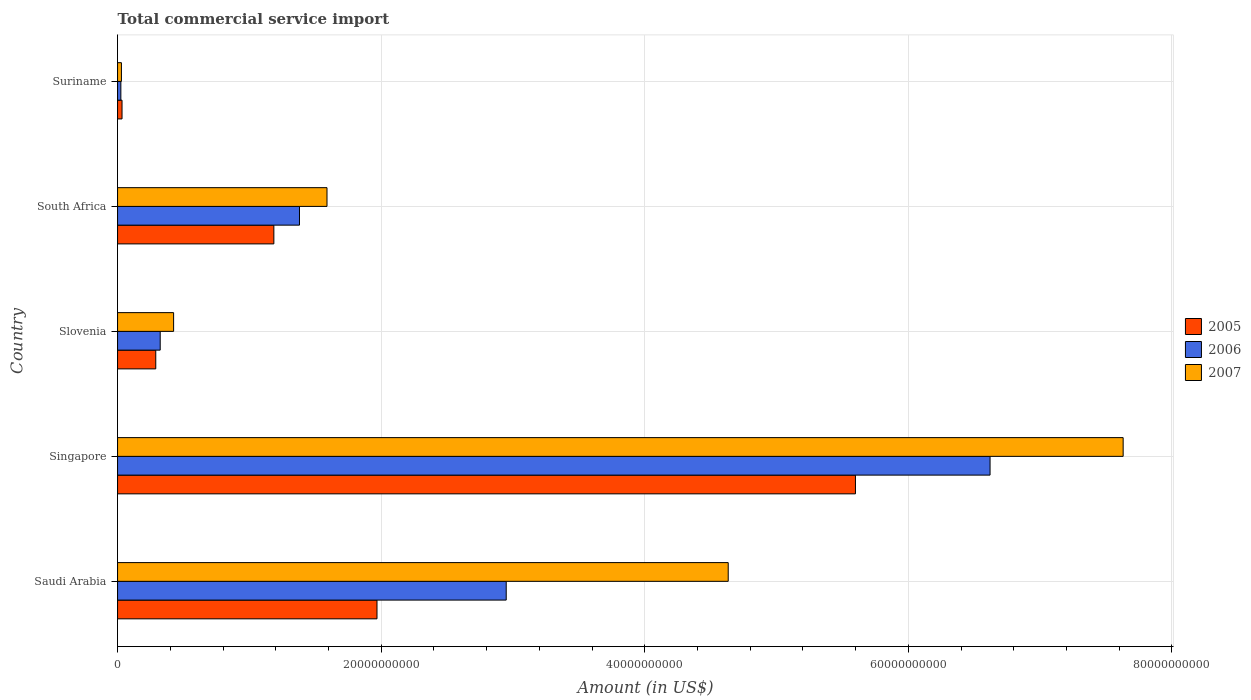How many different coloured bars are there?
Your response must be concise. 3. How many bars are there on the 2nd tick from the top?
Provide a succinct answer. 3. How many bars are there on the 3rd tick from the bottom?
Offer a terse response. 3. What is the label of the 2nd group of bars from the top?
Your response must be concise. South Africa. In how many cases, is the number of bars for a given country not equal to the number of legend labels?
Make the answer very short. 0. What is the total commercial service import in 2006 in South Africa?
Offer a terse response. 1.38e+1. Across all countries, what is the maximum total commercial service import in 2005?
Provide a succinct answer. 5.60e+1. Across all countries, what is the minimum total commercial service import in 2005?
Your answer should be compact. 3.39e+08. In which country was the total commercial service import in 2006 maximum?
Provide a short and direct response. Singapore. In which country was the total commercial service import in 2007 minimum?
Your answer should be very brief. Suriname. What is the total total commercial service import in 2006 in the graph?
Provide a short and direct response. 1.13e+11. What is the difference between the total commercial service import in 2006 in Saudi Arabia and that in South Africa?
Your response must be concise. 1.57e+1. What is the difference between the total commercial service import in 2005 in Saudi Arabia and the total commercial service import in 2006 in Slovenia?
Make the answer very short. 1.64e+1. What is the average total commercial service import in 2005 per country?
Keep it short and to the point. 1.82e+1. What is the difference between the total commercial service import in 2005 and total commercial service import in 2006 in South Africa?
Give a very brief answer. -1.94e+09. What is the ratio of the total commercial service import in 2006 in South Africa to that in Suriname?
Ensure brevity in your answer.  55.01. Is the total commercial service import in 2007 in Singapore less than that in Slovenia?
Provide a succinct answer. No. Is the difference between the total commercial service import in 2005 in Saudi Arabia and South Africa greater than the difference between the total commercial service import in 2006 in Saudi Arabia and South Africa?
Offer a very short reply. No. What is the difference between the highest and the second highest total commercial service import in 2006?
Your answer should be compact. 3.67e+1. What is the difference between the highest and the lowest total commercial service import in 2005?
Keep it short and to the point. 5.56e+1. In how many countries, is the total commercial service import in 2006 greater than the average total commercial service import in 2006 taken over all countries?
Keep it short and to the point. 2. What does the 2nd bar from the bottom in Suriname represents?
Give a very brief answer. 2006. Is it the case that in every country, the sum of the total commercial service import in 2006 and total commercial service import in 2007 is greater than the total commercial service import in 2005?
Provide a short and direct response. Yes. Are all the bars in the graph horizontal?
Your answer should be very brief. Yes. What is the difference between two consecutive major ticks on the X-axis?
Your answer should be very brief. 2.00e+1. Are the values on the major ticks of X-axis written in scientific E-notation?
Give a very brief answer. No. Does the graph contain any zero values?
Provide a succinct answer. No. Does the graph contain grids?
Give a very brief answer. Yes. How many legend labels are there?
Make the answer very short. 3. What is the title of the graph?
Offer a very short reply. Total commercial service import. Does "1964" appear as one of the legend labels in the graph?
Keep it short and to the point. No. What is the label or title of the Y-axis?
Make the answer very short. Country. What is the Amount (in US$) of 2005 in Saudi Arabia?
Your answer should be compact. 1.97e+1. What is the Amount (in US$) in 2006 in Saudi Arabia?
Make the answer very short. 2.95e+1. What is the Amount (in US$) of 2007 in Saudi Arabia?
Your answer should be very brief. 4.63e+1. What is the Amount (in US$) of 2005 in Singapore?
Ensure brevity in your answer.  5.60e+1. What is the Amount (in US$) of 2006 in Singapore?
Your answer should be very brief. 6.62e+1. What is the Amount (in US$) of 2007 in Singapore?
Provide a short and direct response. 7.63e+1. What is the Amount (in US$) of 2005 in Slovenia?
Your response must be concise. 2.90e+09. What is the Amount (in US$) of 2006 in Slovenia?
Offer a terse response. 3.24e+09. What is the Amount (in US$) in 2007 in Slovenia?
Your answer should be very brief. 4.25e+09. What is the Amount (in US$) of 2005 in South Africa?
Offer a terse response. 1.19e+1. What is the Amount (in US$) in 2006 in South Africa?
Offer a very short reply. 1.38e+1. What is the Amount (in US$) in 2007 in South Africa?
Keep it short and to the point. 1.59e+1. What is the Amount (in US$) in 2005 in Suriname?
Give a very brief answer. 3.39e+08. What is the Amount (in US$) in 2006 in Suriname?
Your response must be concise. 2.51e+08. What is the Amount (in US$) in 2007 in Suriname?
Offer a very short reply. 2.93e+08. Across all countries, what is the maximum Amount (in US$) of 2005?
Your answer should be compact. 5.60e+1. Across all countries, what is the maximum Amount (in US$) of 2006?
Keep it short and to the point. 6.62e+1. Across all countries, what is the maximum Amount (in US$) of 2007?
Your answer should be compact. 7.63e+1. Across all countries, what is the minimum Amount (in US$) of 2005?
Offer a terse response. 3.39e+08. Across all countries, what is the minimum Amount (in US$) in 2006?
Keep it short and to the point. 2.51e+08. Across all countries, what is the minimum Amount (in US$) in 2007?
Offer a very short reply. 2.93e+08. What is the total Amount (in US$) of 2005 in the graph?
Provide a short and direct response. 9.08e+1. What is the total Amount (in US$) in 2006 in the graph?
Offer a terse response. 1.13e+11. What is the total Amount (in US$) in 2007 in the graph?
Give a very brief answer. 1.43e+11. What is the difference between the Amount (in US$) of 2005 in Saudi Arabia and that in Singapore?
Provide a short and direct response. -3.63e+1. What is the difference between the Amount (in US$) of 2006 in Saudi Arabia and that in Singapore?
Offer a terse response. -3.67e+1. What is the difference between the Amount (in US$) of 2007 in Saudi Arabia and that in Singapore?
Offer a terse response. -3.00e+1. What is the difference between the Amount (in US$) in 2005 in Saudi Arabia and that in Slovenia?
Offer a terse response. 1.68e+1. What is the difference between the Amount (in US$) in 2006 in Saudi Arabia and that in Slovenia?
Your answer should be very brief. 2.63e+1. What is the difference between the Amount (in US$) in 2007 in Saudi Arabia and that in Slovenia?
Ensure brevity in your answer.  4.21e+1. What is the difference between the Amount (in US$) in 2005 in Saudi Arabia and that in South Africa?
Your answer should be very brief. 7.82e+09. What is the difference between the Amount (in US$) of 2006 in Saudi Arabia and that in South Africa?
Give a very brief answer. 1.57e+1. What is the difference between the Amount (in US$) in 2007 in Saudi Arabia and that in South Africa?
Your response must be concise. 3.04e+1. What is the difference between the Amount (in US$) of 2005 in Saudi Arabia and that in Suriname?
Provide a succinct answer. 1.93e+1. What is the difference between the Amount (in US$) in 2006 in Saudi Arabia and that in Suriname?
Provide a short and direct response. 2.92e+1. What is the difference between the Amount (in US$) of 2007 in Saudi Arabia and that in Suriname?
Keep it short and to the point. 4.60e+1. What is the difference between the Amount (in US$) in 2005 in Singapore and that in Slovenia?
Ensure brevity in your answer.  5.31e+1. What is the difference between the Amount (in US$) of 2006 in Singapore and that in Slovenia?
Provide a succinct answer. 6.30e+1. What is the difference between the Amount (in US$) of 2007 in Singapore and that in Slovenia?
Make the answer very short. 7.20e+1. What is the difference between the Amount (in US$) of 2005 in Singapore and that in South Africa?
Your answer should be compact. 4.41e+1. What is the difference between the Amount (in US$) in 2006 in Singapore and that in South Africa?
Keep it short and to the point. 5.24e+1. What is the difference between the Amount (in US$) of 2007 in Singapore and that in South Africa?
Make the answer very short. 6.04e+1. What is the difference between the Amount (in US$) of 2005 in Singapore and that in Suriname?
Give a very brief answer. 5.56e+1. What is the difference between the Amount (in US$) in 2006 in Singapore and that in Suriname?
Your answer should be compact. 6.59e+1. What is the difference between the Amount (in US$) in 2007 in Singapore and that in Suriname?
Keep it short and to the point. 7.60e+1. What is the difference between the Amount (in US$) of 2005 in Slovenia and that in South Africa?
Your answer should be very brief. -8.96e+09. What is the difference between the Amount (in US$) in 2006 in Slovenia and that in South Africa?
Your answer should be very brief. -1.06e+1. What is the difference between the Amount (in US$) of 2007 in Slovenia and that in South Africa?
Your response must be concise. -1.16e+1. What is the difference between the Amount (in US$) in 2005 in Slovenia and that in Suriname?
Offer a terse response. 2.56e+09. What is the difference between the Amount (in US$) in 2006 in Slovenia and that in Suriname?
Keep it short and to the point. 2.98e+09. What is the difference between the Amount (in US$) of 2007 in Slovenia and that in Suriname?
Your answer should be very brief. 3.96e+09. What is the difference between the Amount (in US$) of 2005 in South Africa and that in Suriname?
Your response must be concise. 1.15e+1. What is the difference between the Amount (in US$) in 2006 in South Africa and that in Suriname?
Give a very brief answer. 1.36e+1. What is the difference between the Amount (in US$) of 2007 in South Africa and that in Suriname?
Provide a short and direct response. 1.56e+1. What is the difference between the Amount (in US$) in 2005 in Saudi Arabia and the Amount (in US$) in 2006 in Singapore?
Give a very brief answer. -4.65e+1. What is the difference between the Amount (in US$) in 2005 in Saudi Arabia and the Amount (in US$) in 2007 in Singapore?
Ensure brevity in your answer.  -5.66e+1. What is the difference between the Amount (in US$) of 2006 in Saudi Arabia and the Amount (in US$) of 2007 in Singapore?
Keep it short and to the point. -4.68e+1. What is the difference between the Amount (in US$) in 2005 in Saudi Arabia and the Amount (in US$) in 2006 in Slovenia?
Give a very brief answer. 1.64e+1. What is the difference between the Amount (in US$) of 2005 in Saudi Arabia and the Amount (in US$) of 2007 in Slovenia?
Provide a succinct answer. 1.54e+1. What is the difference between the Amount (in US$) in 2006 in Saudi Arabia and the Amount (in US$) in 2007 in Slovenia?
Make the answer very short. 2.52e+1. What is the difference between the Amount (in US$) in 2005 in Saudi Arabia and the Amount (in US$) in 2006 in South Africa?
Ensure brevity in your answer.  5.88e+09. What is the difference between the Amount (in US$) of 2005 in Saudi Arabia and the Amount (in US$) of 2007 in South Africa?
Make the answer very short. 3.79e+09. What is the difference between the Amount (in US$) of 2006 in Saudi Arabia and the Amount (in US$) of 2007 in South Africa?
Provide a succinct answer. 1.36e+1. What is the difference between the Amount (in US$) in 2005 in Saudi Arabia and the Amount (in US$) in 2006 in Suriname?
Make the answer very short. 1.94e+1. What is the difference between the Amount (in US$) of 2005 in Saudi Arabia and the Amount (in US$) of 2007 in Suriname?
Give a very brief answer. 1.94e+1. What is the difference between the Amount (in US$) of 2006 in Saudi Arabia and the Amount (in US$) of 2007 in Suriname?
Your answer should be very brief. 2.92e+1. What is the difference between the Amount (in US$) of 2005 in Singapore and the Amount (in US$) of 2006 in Slovenia?
Give a very brief answer. 5.27e+1. What is the difference between the Amount (in US$) in 2005 in Singapore and the Amount (in US$) in 2007 in Slovenia?
Ensure brevity in your answer.  5.17e+1. What is the difference between the Amount (in US$) of 2006 in Singapore and the Amount (in US$) of 2007 in Slovenia?
Provide a short and direct response. 6.19e+1. What is the difference between the Amount (in US$) of 2005 in Singapore and the Amount (in US$) of 2006 in South Africa?
Provide a succinct answer. 4.22e+1. What is the difference between the Amount (in US$) of 2005 in Singapore and the Amount (in US$) of 2007 in South Africa?
Ensure brevity in your answer.  4.01e+1. What is the difference between the Amount (in US$) in 2006 in Singapore and the Amount (in US$) in 2007 in South Africa?
Your answer should be very brief. 5.03e+1. What is the difference between the Amount (in US$) in 2005 in Singapore and the Amount (in US$) in 2006 in Suriname?
Your answer should be very brief. 5.57e+1. What is the difference between the Amount (in US$) in 2005 in Singapore and the Amount (in US$) in 2007 in Suriname?
Keep it short and to the point. 5.57e+1. What is the difference between the Amount (in US$) in 2006 in Singapore and the Amount (in US$) in 2007 in Suriname?
Offer a very short reply. 6.59e+1. What is the difference between the Amount (in US$) of 2005 in Slovenia and the Amount (in US$) of 2006 in South Africa?
Provide a succinct answer. -1.09e+1. What is the difference between the Amount (in US$) of 2005 in Slovenia and the Amount (in US$) of 2007 in South Africa?
Ensure brevity in your answer.  -1.30e+1. What is the difference between the Amount (in US$) of 2006 in Slovenia and the Amount (in US$) of 2007 in South Africa?
Provide a succinct answer. -1.27e+1. What is the difference between the Amount (in US$) of 2005 in Slovenia and the Amount (in US$) of 2006 in Suriname?
Ensure brevity in your answer.  2.65e+09. What is the difference between the Amount (in US$) in 2005 in Slovenia and the Amount (in US$) in 2007 in Suriname?
Offer a very short reply. 2.61e+09. What is the difference between the Amount (in US$) in 2006 in Slovenia and the Amount (in US$) in 2007 in Suriname?
Ensure brevity in your answer.  2.94e+09. What is the difference between the Amount (in US$) of 2005 in South Africa and the Amount (in US$) of 2006 in Suriname?
Make the answer very short. 1.16e+1. What is the difference between the Amount (in US$) in 2005 in South Africa and the Amount (in US$) in 2007 in Suriname?
Your response must be concise. 1.16e+1. What is the difference between the Amount (in US$) of 2006 in South Africa and the Amount (in US$) of 2007 in Suriname?
Keep it short and to the point. 1.35e+1. What is the average Amount (in US$) in 2005 per country?
Offer a terse response. 1.82e+1. What is the average Amount (in US$) of 2006 per country?
Make the answer very short. 2.26e+1. What is the average Amount (in US$) in 2007 per country?
Your answer should be very brief. 2.86e+1. What is the difference between the Amount (in US$) in 2005 and Amount (in US$) in 2006 in Saudi Arabia?
Provide a succinct answer. -9.80e+09. What is the difference between the Amount (in US$) of 2005 and Amount (in US$) of 2007 in Saudi Arabia?
Your response must be concise. -2.66e+1. What is the difference between the Amount (in US$) in 2006 and Amount (in US$) in 2007 in Saudi Arabia?
Provide a succinct answer. -1.68e+1. What is the difference between the Amount (in US$) in 2005 and Amount (in US$) in 2006 in Singapore?
Offer a very short reply. -1.02e+1. What is the difference between the Amount (in US$) in 2005 and Amount (in US$) in 2007 in Singapore?
Your answer should be very brief. -2.03e+1. What is the difference between the Amount (in US$) in 2006 and Amount (in US$) in 2007 in Singapore?
Keep it short and to the point. -1.01e+1. What is the difference between the Amount (in US$) in 2005 and Amount (in US$) in 2006 in Slovenia?
Give a very brief answer. -3.36e+08. What is the difference between the Amount (in US$) of 2005 and Amount (in US$) of 2007 in Slovenia?
Give a very brief answer. -1.35e+09. What is the difference between the Amount (in US$) in 2006 and Amount (in US$) in 2007 in Slovenia?
Offer a terse response. -1.02e+09. What is the difference between the Amount (in US$) of 2005 and Amount (in US$) of 2006 in South Africa?
Your answer should be compact. -1.94e+09. What is the difference between the Amount (in US$) of 2005 and Amount (in US$) of 2007 in South Africa?
Make the answer very short. -4.03e+09. What is the difference between the Amount (in US$) of 2006 and Amount (in US$) of 2007 in South Africa?
Give a very brief answer. -2.09e+09. What is the difference between the Amount (in US$) of 2005 and Amount (in US$) of 2006 in Suriname?
Keep it short and to the point. 8.83e+07. What is the difference between the Amount (in US$) in 2005 and Amount (in US$) in 2007 in Suriname?
Give a very brief answer. 4.63e+07. What is the difference between the Amount (in US$) in 2006 and Amount (in US$) in 2007 in Suriname?
Offer a terse response. -4.20e+07. What is the ratio of the Amount (in US$) of 2005 in Saudi Arabia to that in Singapore?
Keep it short and to the point. 0.35. What is the ratio of the Amount (in US$) of 2006 in Saudi Arabia to that in Singapore?
Provide a short and direct response. 0.45. What is the ratio of the Amount (in US$) of 2007 in Saudi Arabia to that in Singapore?
Keep it short and to the point. 0.61. What is the ratio of the Amount (in US$) of 2005 in Saudi Arabia to that in Slovenia?
Offer a terse response. 6.79. What is the ratio of the Amount (in US$) in 2006 in Saudi Arabia to that in Slovenia?
Make the answer very short. 9.11. What is the ratio of the Amount (in US$) of 2007 in Saudi Arabia to that in Slovenia?
Ensure brevity in your answer.  10.89. What is the ratio of the Amount (in US$) of 2005 in Saudi Arabia to that in South Africa?
Keep it short and to the point. 1.66. What is the ratio of the Amount (in US$) of 2006 in Saudi Arabia to that in South Africa?
Your answer should be compact. 2.14. What is the ratio of the Amount (in US$) in 2007 in Saudi Arabia to that in South Africa?
Offer a terse response. 2.92. What is the ratio of the Amount (in US$) of 2005 in Saudi Arabia to that in Suriname?
Keep it short and to the point. 58.03. What is the ratio of the Amount (in US$) in 2006 in Saudi Arabia to that in Suriname?
Give a very brief answer. 117.53. What is the ratio of the Amount (in US$) of 2007 in Saudi Arabia to that in Suriname?
Provide a succinct answer. 158.18. What is the ratio of the Amount (in US$) in 2005 in Singapore to that in Slovenia?
Provide a short and direct response. 19.31. What is the ratio of the Amount (in US$) of 2006 in Singapore to that in Slovenia?
Your answer should be compact. 20.46. What is the ratio of the Amount (in US$) of 2007 in Singapore to that in Slovenia?
Offer a very short reply. 17.94. What is the ratio of the Amount (in US$) in 2005 in Singapore to that in South Africa?
Make the answer very short. 4.72. What is the ratio of the Amount (in US$) in 2006 in Singapore to that in South Africa?
Your response must be concise. 4.8. What is the ratio of the Amount (in US$) of 2007 in Singapore to that in South Africa?
Ensure brevity in your answer.  4.8. What is the ratio of the Amount (in US$) in 2005 in Singapore to that in Suriname?
Ensure brevity in your answer.  165.05. What is the ratio of the Amount (in US$) of 2006 in Singapore to that in Suriname?
Make the answer very short. 263.84. What is the ratio of the Amount (in US$) of 2007 in Singapore to that in Suriname?
Keep it short and to the point. 260.48. What is the ratio of the Amount (in US$) of 2005 in Slovenia to that in South Africa?
Offer a terse response. 0.24. What is the ratio of the Amount (in US$) in 2006 in Slovenia to that in South Africa?
Your answer should be very brief. 0.23. What is the ratio of the Amount (in US$) in 2007 in Slovenia to that in South Africa?
Ensure brevity in your answer.  0.27. What is the ratio of the Amount (in US$) in 2005 in Slovenia to that in Suriname?
Your answer should be compact. 8.55. What is the ratio of the Amount (in US$) in 2006 in Slovenia to that in Suriname?
Offer a terse response. 12.9. What is the ratio of the Amount (in US$) in 2007 in Slovenia to that in Suriname?
Your response must be concise. 14.52. What is the ratio of the Amount (in US$) in 2005 in South Africa to that in Suriname?
Keep it short and to the point. 34.96. What is the ratio of the Amount (in US$) of 2006 in South Africa to that in Suriname?
Ensure brevity in your answer.  55.01. What is the ratio of the Amount (in US$) of 2007 in South Africa to that in Suriname?
Make the answer very short. 54.25. What is the difference between the highest and the second highest Amount (in US$) of 2005?
Ensure brevity in your answer.  3.63e+1. What is the difference between the highest and the second highest Amount (in US$) of 2006?
Provide a succinct answer. 3.67e+1. What is the difference between the highest and the second highest Amount (in US$) in 2007?
Make the answer very short. 3.00e+1. What is the difference between the highest and the lowest Amount (in US$) of 2005?
Your answer should be compact. 5.56e+1. What is the difference between the highest and the lowest Amount (in US$) of 2006?
Keep it short and to the point. 6.59e+1. What is the difference between the highest and the lowest Amount (in US$) of 2007?
Make the answer very short. 7.60e+1. 